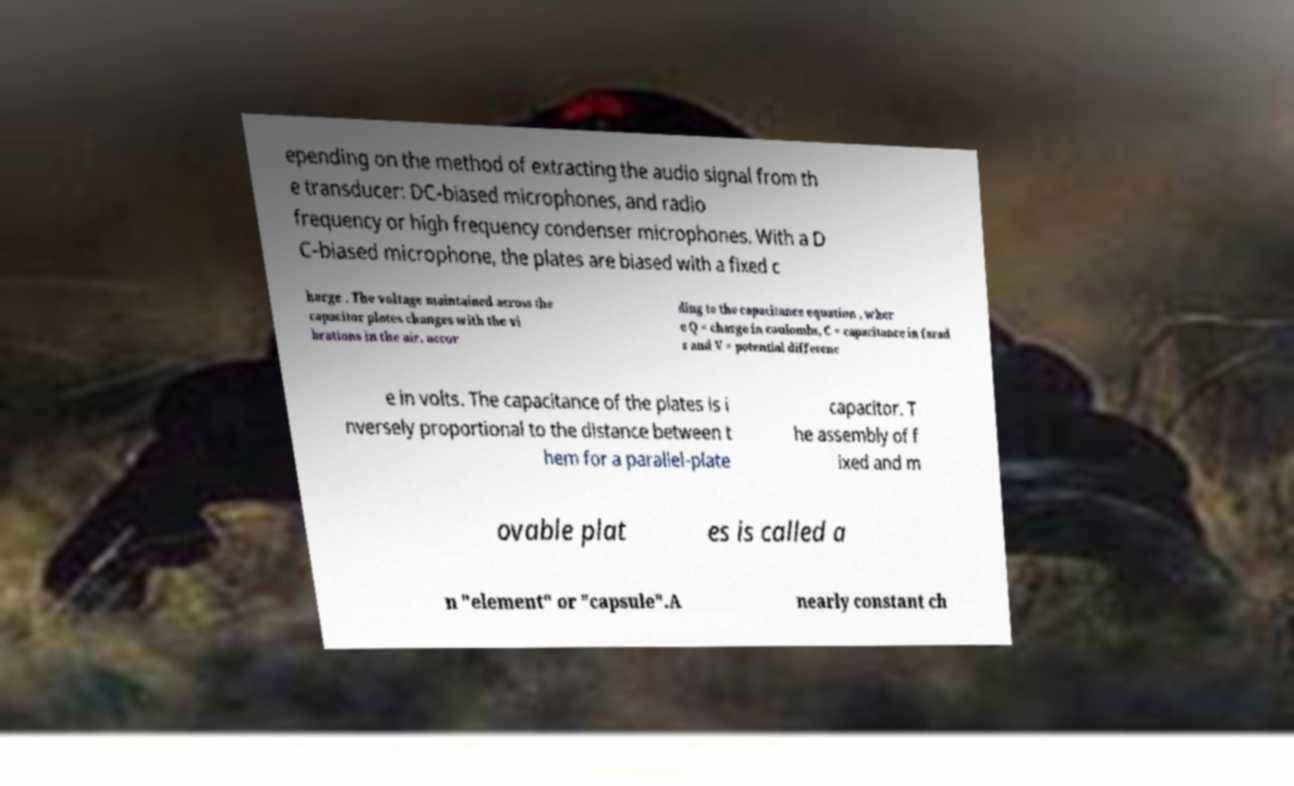Can you read and provide the text displayed in the image?This photo seems to have some interesting text. Can you extract and type it out for me? epending on the method of extracting the audio signal from th e transducer: DC-biased microphones, and radio frequency or high frequency condenser microphones. With a D C-biased microphone, the plates are biased with a fixed c harge . The voltage maintained across the capacitor plates changes with the vi brations in the air, accor ding to the capacitance equation , wher e Q = charge in coulombs, C = capacitance in farad s and V = potential differenc e in volts. The capacitance of the plates is i nversely proportional to the distance between t hem for a parallel-plate capacitor. T he assembly of f ixed and m ovable plat es is called a n "element" or "capsule".A nearly constant ch 